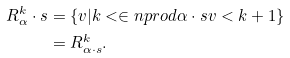Convert formula to latex. <formula><loc_0><loc_0><loc_500><loc_500>R ^ { k } _ { \alpha } \cdot s & = \{ v | k < \in n p r o d { \alpha \cdot s } { v } < k + 1 \} \\ & = R ^ { k } _ { \alpha \cdot s } .</formula> 